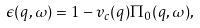Convert formula to latex. <formula><loc_0><loc_0><loc_500><loc_500>\epsilon ( q , \omega ) = 1 - v _ { c } ( q ) \Pi _ { 0 } ( q , \omega ) ,</formula> 